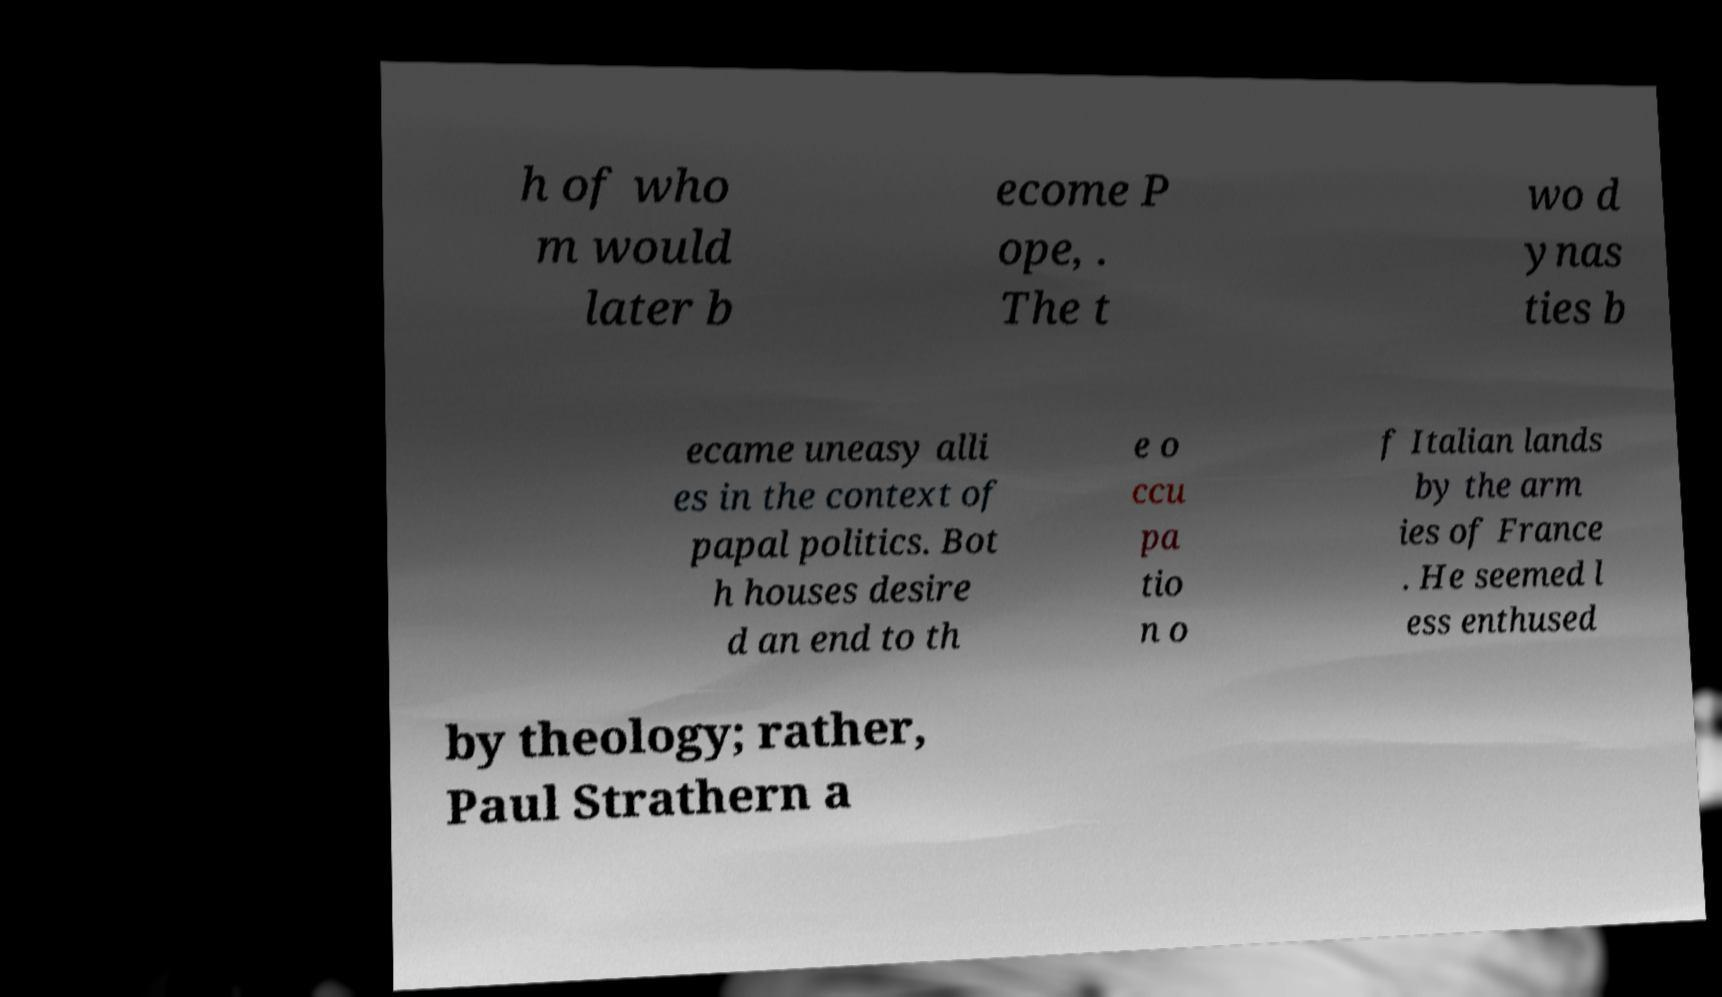Can you read and provide the text displayed in the image?This photo seems to have some interesting text. Can you extract and type it out for me? h of who m would later b ecome P ope, . The t wo d ynas ties b ecame uneasy alli es in the context of papal politics. Bot h houses desire d an end to th e o ccu pa tio n o f Italian lands by the arm ies of France . He seemed l ess enthused by theology; rather, Paul Strathern a 